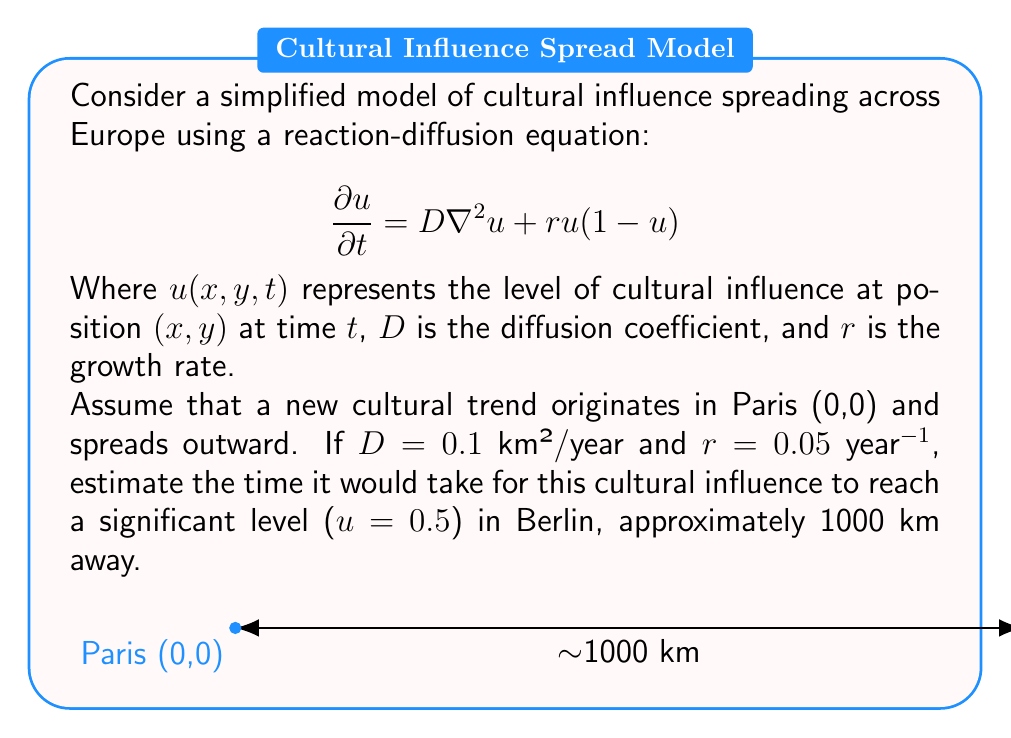Help me with this question. To solve this problem, we'll use the concept of wave speed in reaction-diffusion equations:

1) For a reaction-diffusion equation of the form $$\frac{\partial u}{\partial t} = D\nabla^2u + f(u)$$
   where $f(u) = ru(1-u)$, the wave speed $c$ is given by:
   
   $$c = 2\sqrt{Dr}$$

2) Substituting the given values:
   $D = 0.1$ km²/year
   $r = 0.05$ year⁻¹
   
   $$c = 2\sqrt{0.1 \times 0.05} = 2\sqrt{0.005} \approx 0.1414$$ km/year

3) The distance between Paris and Berlin is approximately 1000 km.

4) Time $t$ can be estimated using the simple relation:
   $$t = \frac{\text{distance}}{\text{speed}}$$

5) Therefore:
   $$t = \frac{1000}{0.1414} \approx 7071$$ years

Note: This is a simplified model and doesn't account for many real-world factors that would influence cultural spread, such as communication technologies, political boundaries, or social networks. In reality, cultural influence would spread much faster.
Answer: Approximately 7071 years 